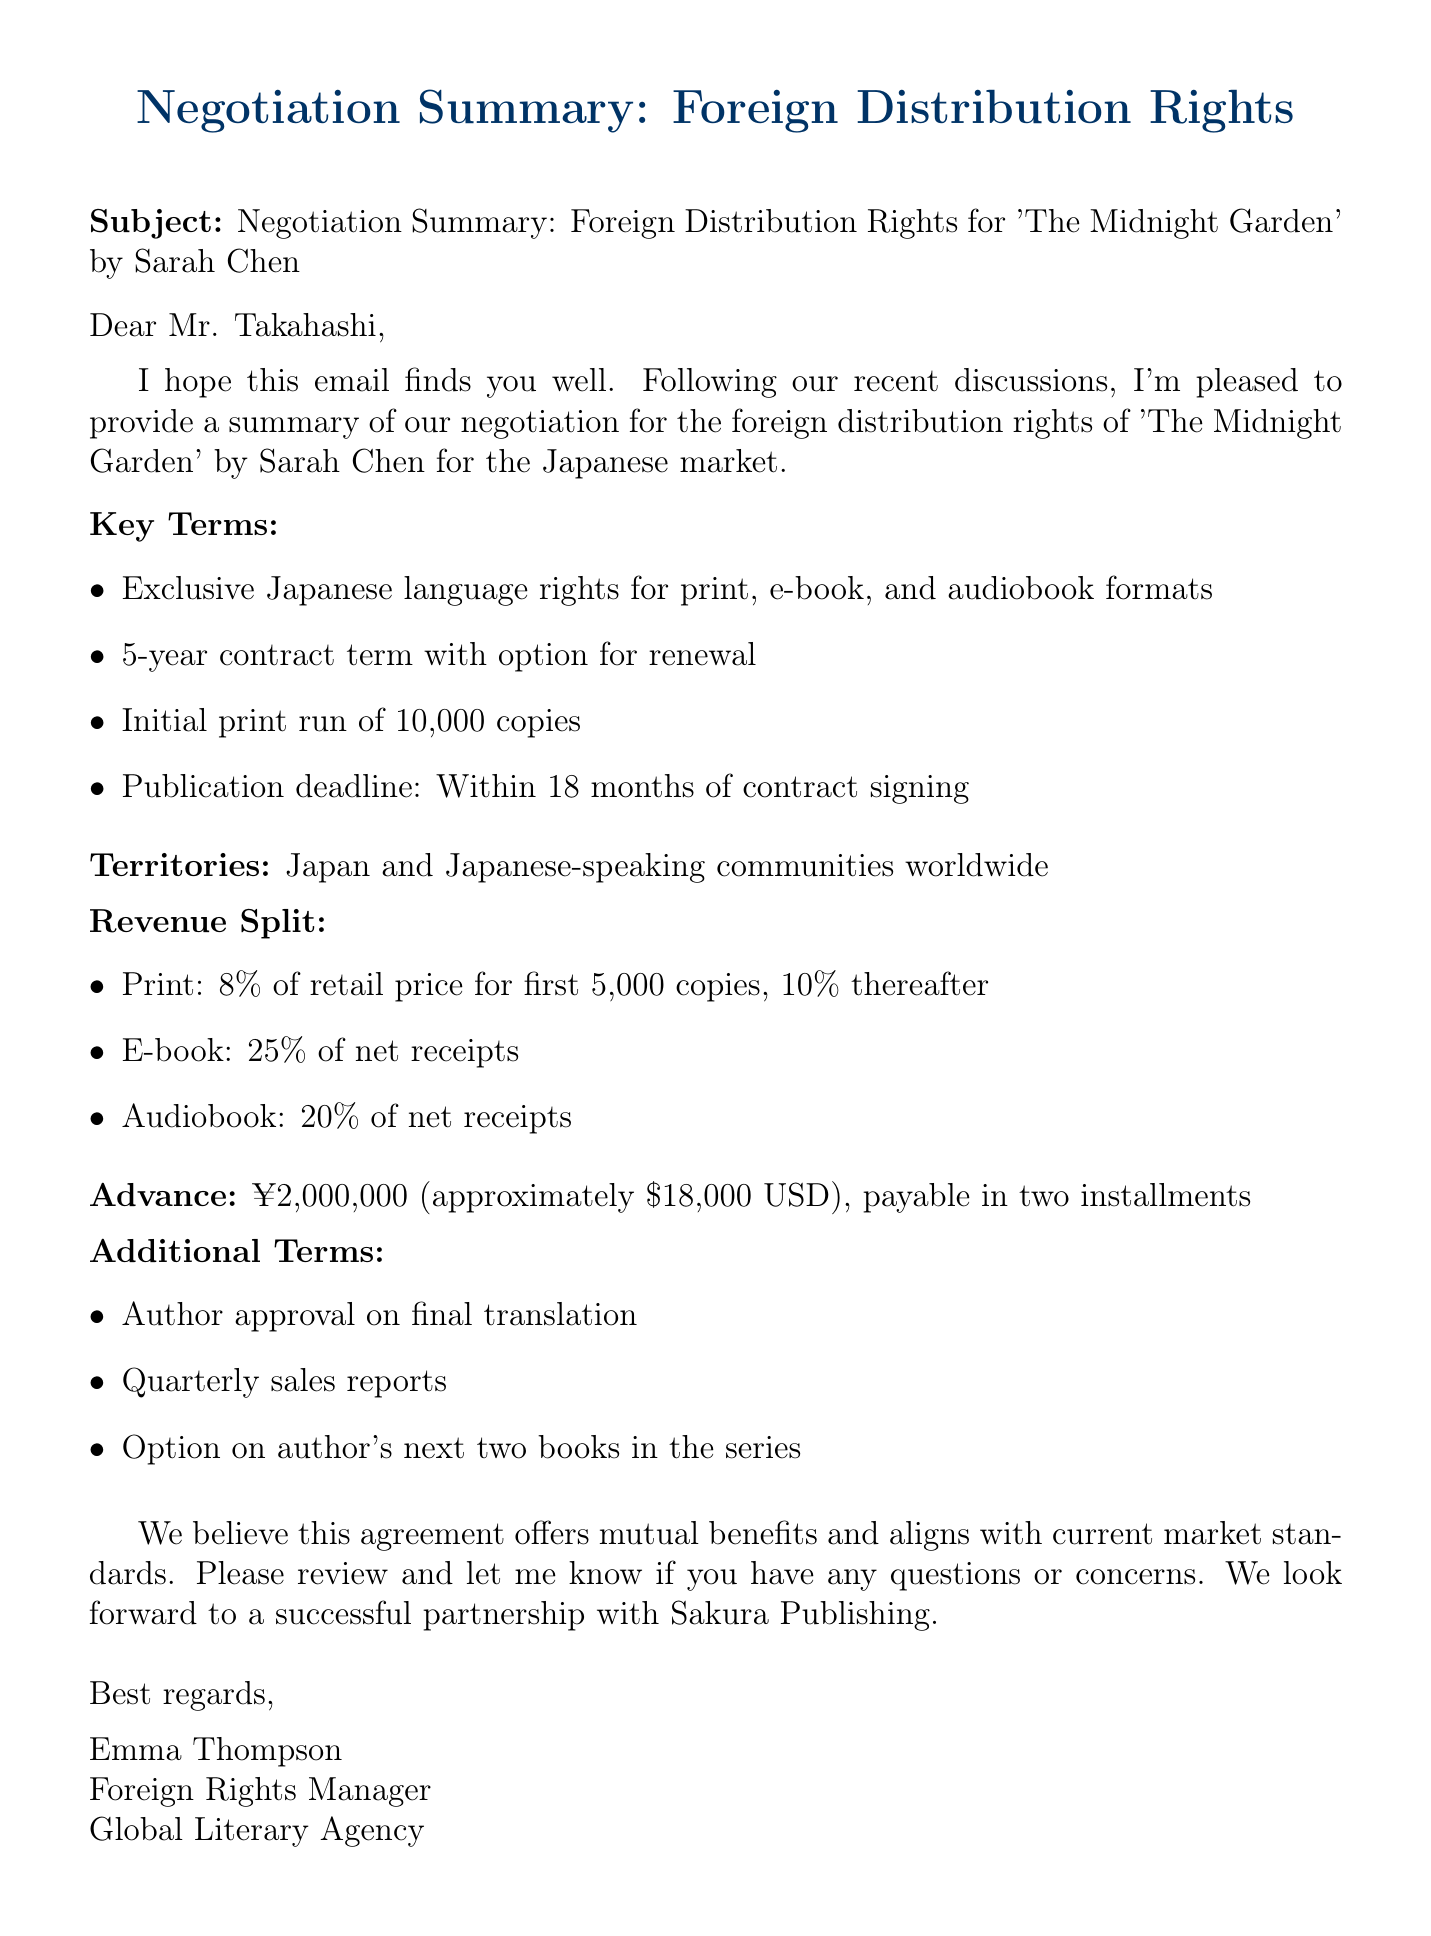What are the exclusive rights granted? The document states that the exclusive rights are for Japanese language rights for print, e-book, and audiobook formats.
Answer: Exclusive Japanese language rights for print, e-book, and audiobook formats What is the duration of the contract? The document specifies a 5-year contract term with an option for renewal.
Answer: 5-year contract term What is the advance payment amount? The advance payment mentioned in the document is stated as ¥2,000,000.
Answer: ¥2,000,000 How many copies are in the initial print run? The initial print run mentioned in the document is stated to be 10,000 copies.
Answer: 10,000 copies What percentage of net receipts will the e-book revenue split be? The document specifies that the e-book revenue split will be 25% of net receipts.
Answer: 25% of net receipts What is the publication deadline after signing the contract? According to the document, the publication deadline is within 18 months of contract signing.
Answer: Within 18 months How frequently will sales reports be provided? The document indicates that quarterly sales reports will be provided.
Answer: Quarterly What is required for the final translation? The document states that the author must approve the final translation.
Answer: Author approval on final translation Which territories are included in the distribution rights? The territories specified in the document are Japan and Japanese-speaking communities worldwide.
Answer: Japan and Japanese-speaking communities worldwide 